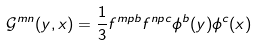<formula> <loc_0><loc_0><loc_500><loc_500>\mathcal { G } ^ { m n } ( y , x ) = \frac { 1 } { 3 } f ^ { m p b } f ^ { n p c } \phi ^ { b } ( y ) \phi ^ { c } ( x )</formula> 